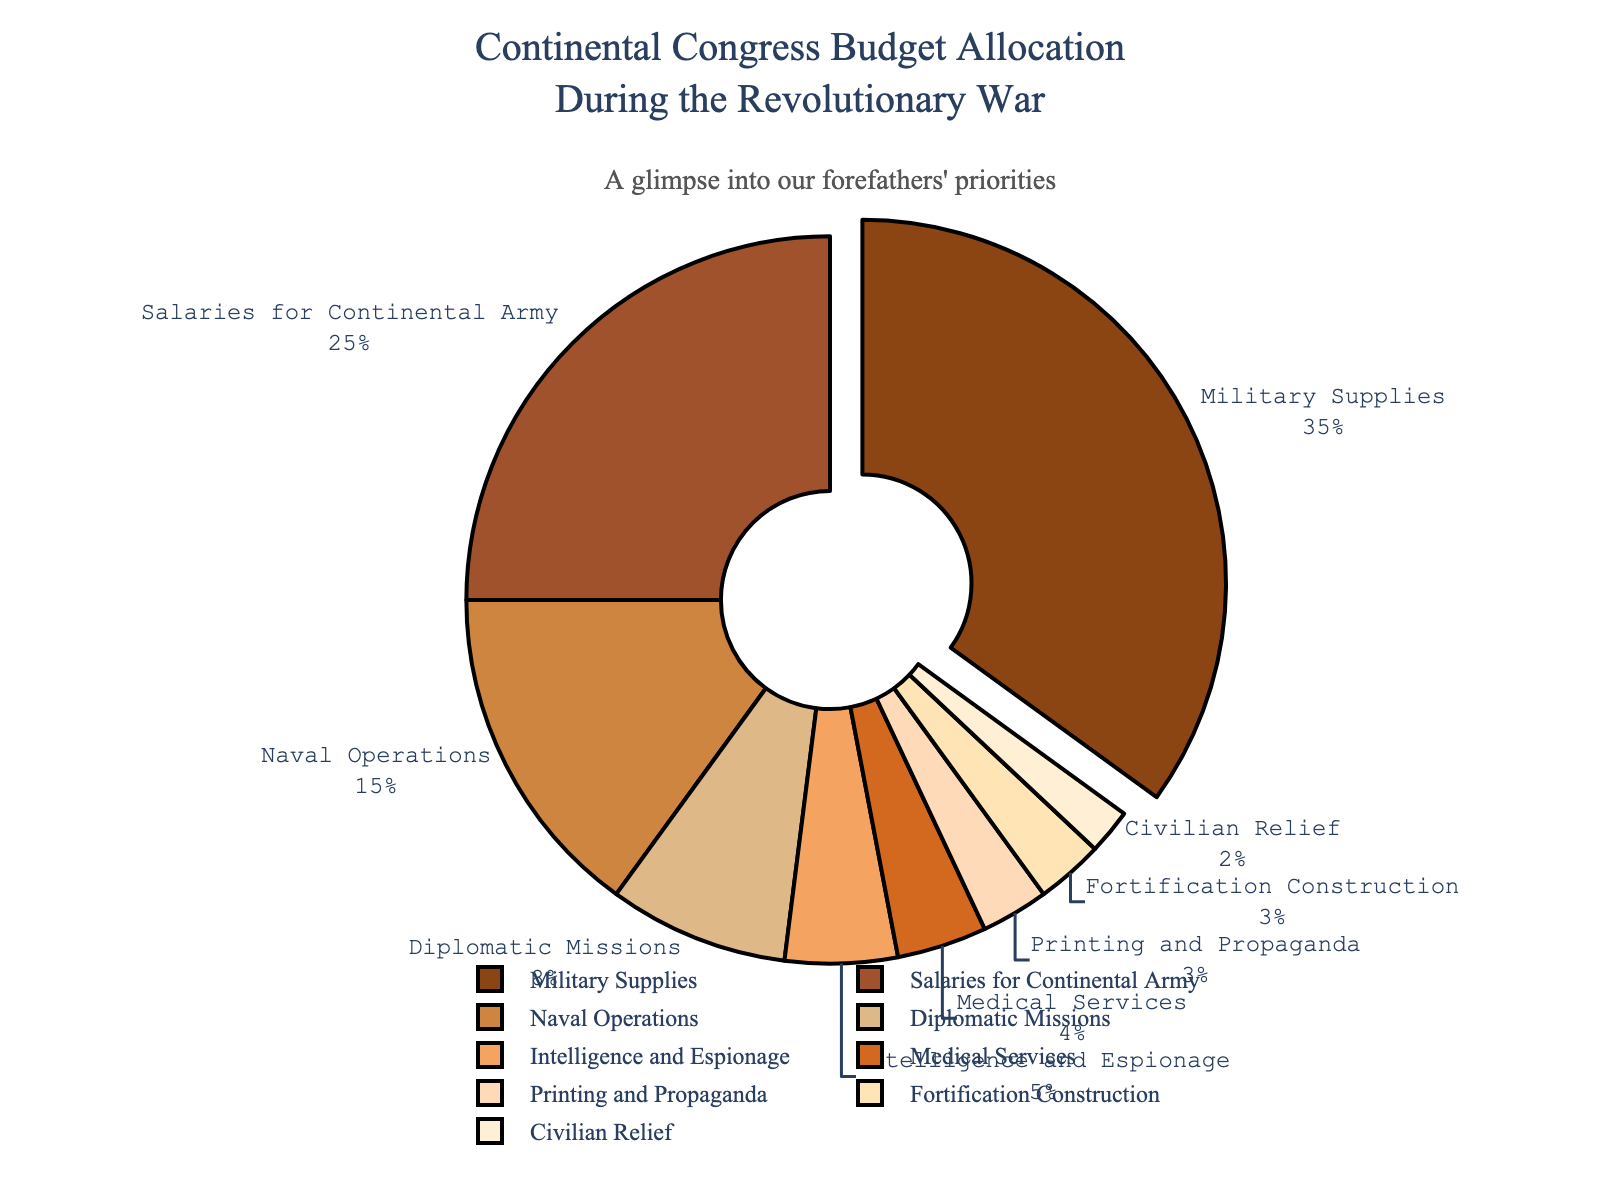What category receives the highest percentage of the budget allocation? The pie chart shows that 'Military Supplies' has the largest slice, which is further emphasized by being pulled out slightly from the pie, indicating it receives the highest percentage.
Answer: Military Supplies Which category gets 5% of the budget allocation? Checking the labels and the associated percentages on the pie chart, the 'Intelligence and Espionage' category is marked with 5%.
Answer: Intelligence and Espionage What is the combined percentage allocated to the 'Medical Services' and 'Printing and Propaganda' categories? According to the pie chart, 'Medical Services' is allocated 4% and 'Printing and Propaganda' is allocated 3%. Summing these gives 4% + 3% = 7%.
Answer: 7% Which category is allocated more, 'Naval Operations' or 'Diplomatic Missions'? By comparing the two percentages on the chart, 'Naval Operations' is allocated 15% while 'Diplomatic Missions' gets 8%. Thus, 'Naval Operations' has a larger allocation.
Answer: Naval Operations How much greater is the percentage for 'Salaries for Continental Army' compared to 'Civilian Relief'? From the chart, 'Salaries for Continental Army' is 25% and 'Civilian Relief' is 2%. The difference is 25% - 2% = 23%.
Answer: 23% What are the three categories with the smallest budget allocations? By looking at the percentages on the pie chart, 'Civilian Relief' (2%), 'Fortification Construction' (3%), and 'Printing and Propaganda' (3%) are the three smallest allocations.
Answer: Civilian Relief, Fortification Construction, Printing and Propaganda Does 'Diplomatic Missions' receive less than or more than 10% of the budget? The pie chart indicates that 'Diplomatic Missions' is assigned 8%, which is less than 10%.
Answer: Less than 10% What's the visual indicator used to highlight the category with the highest budget allocation? The largest percentage category, 'Military Supplies,' is pulled out slightly from the chart to visually emphasize its importance.
Answer: Pulled out slice 